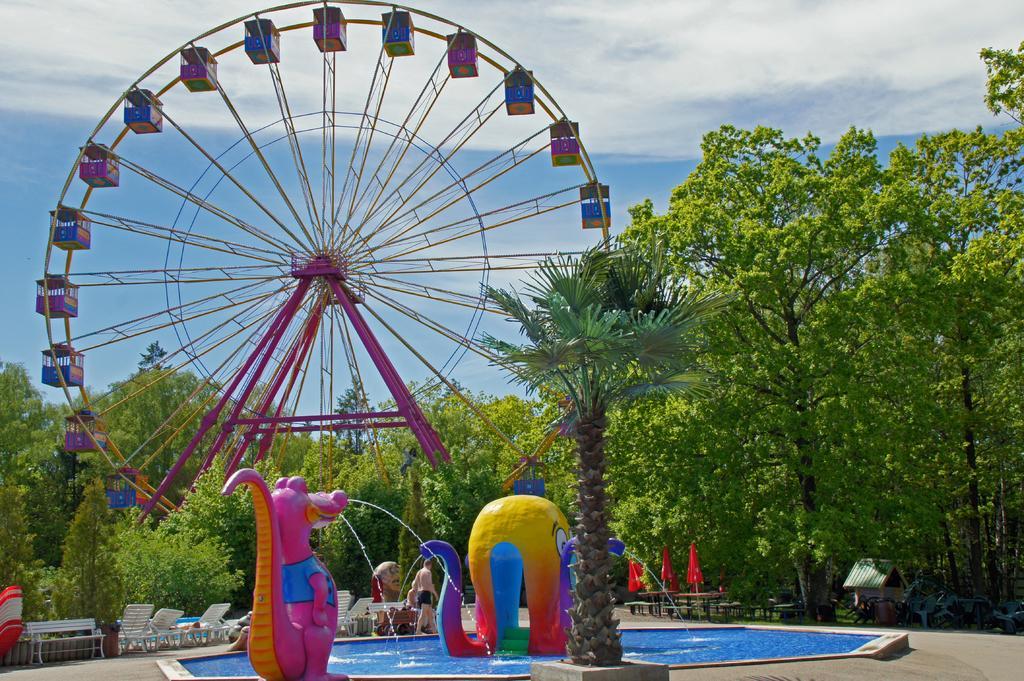How would you summarize this image in a sentence or two? In the image i can see a giant wheelchairs,trees,water,flags,sky and some other objects. 